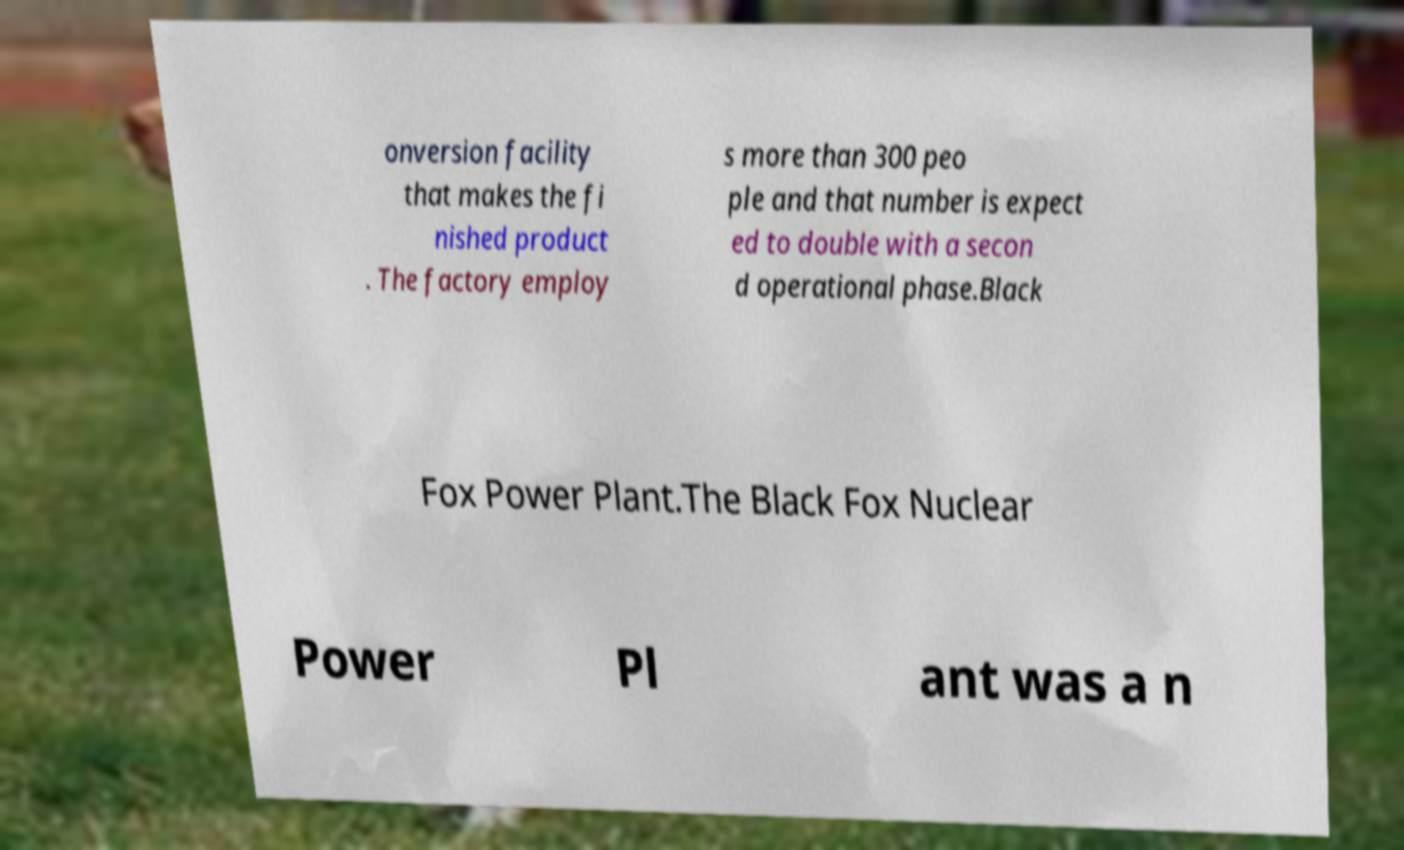There's text embedded in this image that I need extracted. Can you transcribe it verbatim? onversion facility that makes the fi nished product . The factory employ s more than 300 peo ple and that number is expect ed to double with a secon d operational phase.Black Fox Power Plant.The Black Fox Nuclear Power Pl ant was a n 